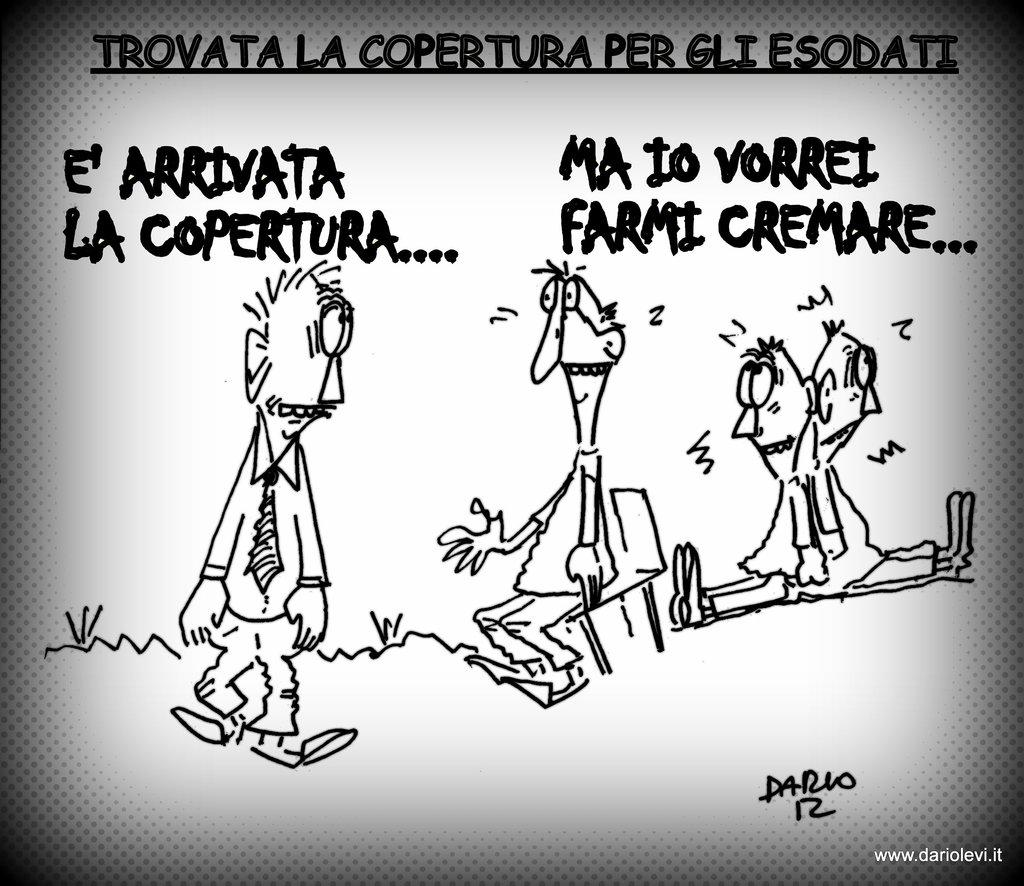How many people are present in the image? There are four people in the image. What are the positions of the people in the image? One person is standing, and one person is sitting on a chair. What else can be seen in the image besides the people? There are words and a watermark in the image. What type of toys are being played with during the recess in the image? There is no recess or toys present in the image. 